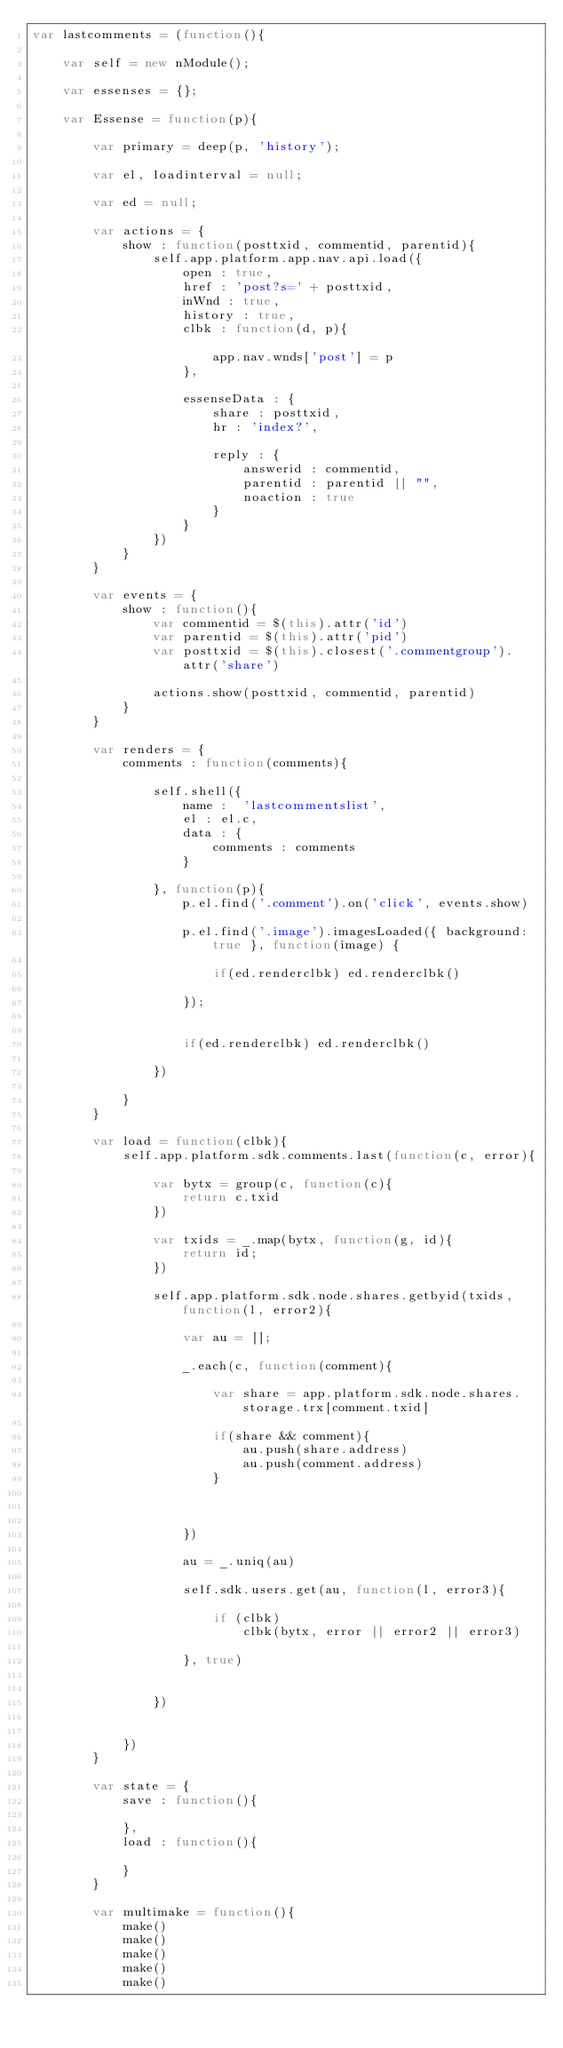<code> <loc_0><loc_0><loc_500><loc_500><_JavaScript_>var lastcomments = (function(){

	var self = new nModule();

	var essenses = {};

	var Essense = function(p){

		var primary = deep(p, 'history');

		var el, loadinterval = null;

		var ed = null;

		var actions = {
			show : function(posttxid, commentid, parentid){
				self.app.platform.app.nav.api.load({
					open : true,
					href : 'post?s=' + posttxid,
					inWnd : true,
					history : true,
					clbk : function(d, p){									
						app.nav.wnds['post'] = p
					},

					essenseData : {
						share : posttxid,
						hr : 'index?',

						reply : {
							answerid : commentid,
							parentid : parentid || "",
							noaction : true
						}
					}
				})
			}
		}

		var events = {
			show : function(){
				var commentid = $(this).attr('id')
				var parentid = $(this).attr('pid')
				var posttxid = $(this).closest('.commentgroup').attr('share')

				actions.show(posttxid, commentid, parentid)
			}
		}

		var renders = {
			comments : function(comments){

				self.shell({
					name :  'lastcommentslist',
					el : el.c,
					data : {
						comments : comments
					}					

				}, function(p){
					p.el.find('.comment').on('click', events.show)

					p.el.find('.image').imagesLoaded({ background: true }, function(image) {

						if(ed.renderclbk) ed.renderclbk()

					});


					if(ed.renderclbk) ed.renderclbk()

				})

			}
		}

		var load = function(clbk){
			self.app.platform.sdk.comments.last(function(c, error){

				var bytx = group(c, function(c){
					return c.txid
				})

				var txids = _.map(bytx, function(g, id){
					return id;
				})

				self.app.platform.sdk.node.shares.getbyid(txids, function(l, error2){

					var au = [];

					_.each(c, function(comment){ 
    
						var share = app.platform.sdk.node.shares.storage.trx[comment.txid]

						if(share && comment){
							au.push(share.address)
							au.push(comment.address)
						}

						

					})

					au = _.uniq(au)

					self.sdk.users.get(au, function(l, error3){

						if (clbk)
							clbk(bytx, error || error2 || error3)

					}, true)

					
				})

				
			})
		}

		var state = {
			save : function(){

			},
			load : function(){
				
			}
		}

		var multimake = function(){
			make()
			make()
			make()
			make()
			make()</code> 